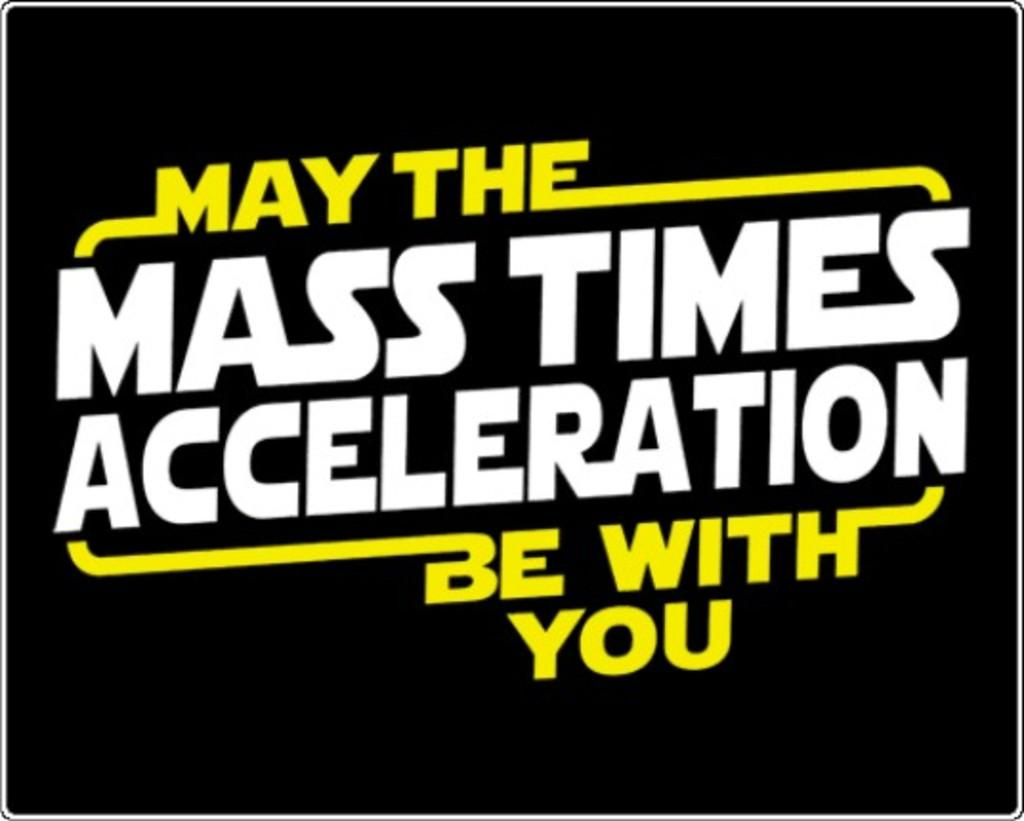<image>
Relay a brief, clear account of the picture shown. a quote that has the phrase mass times acceleration on it 